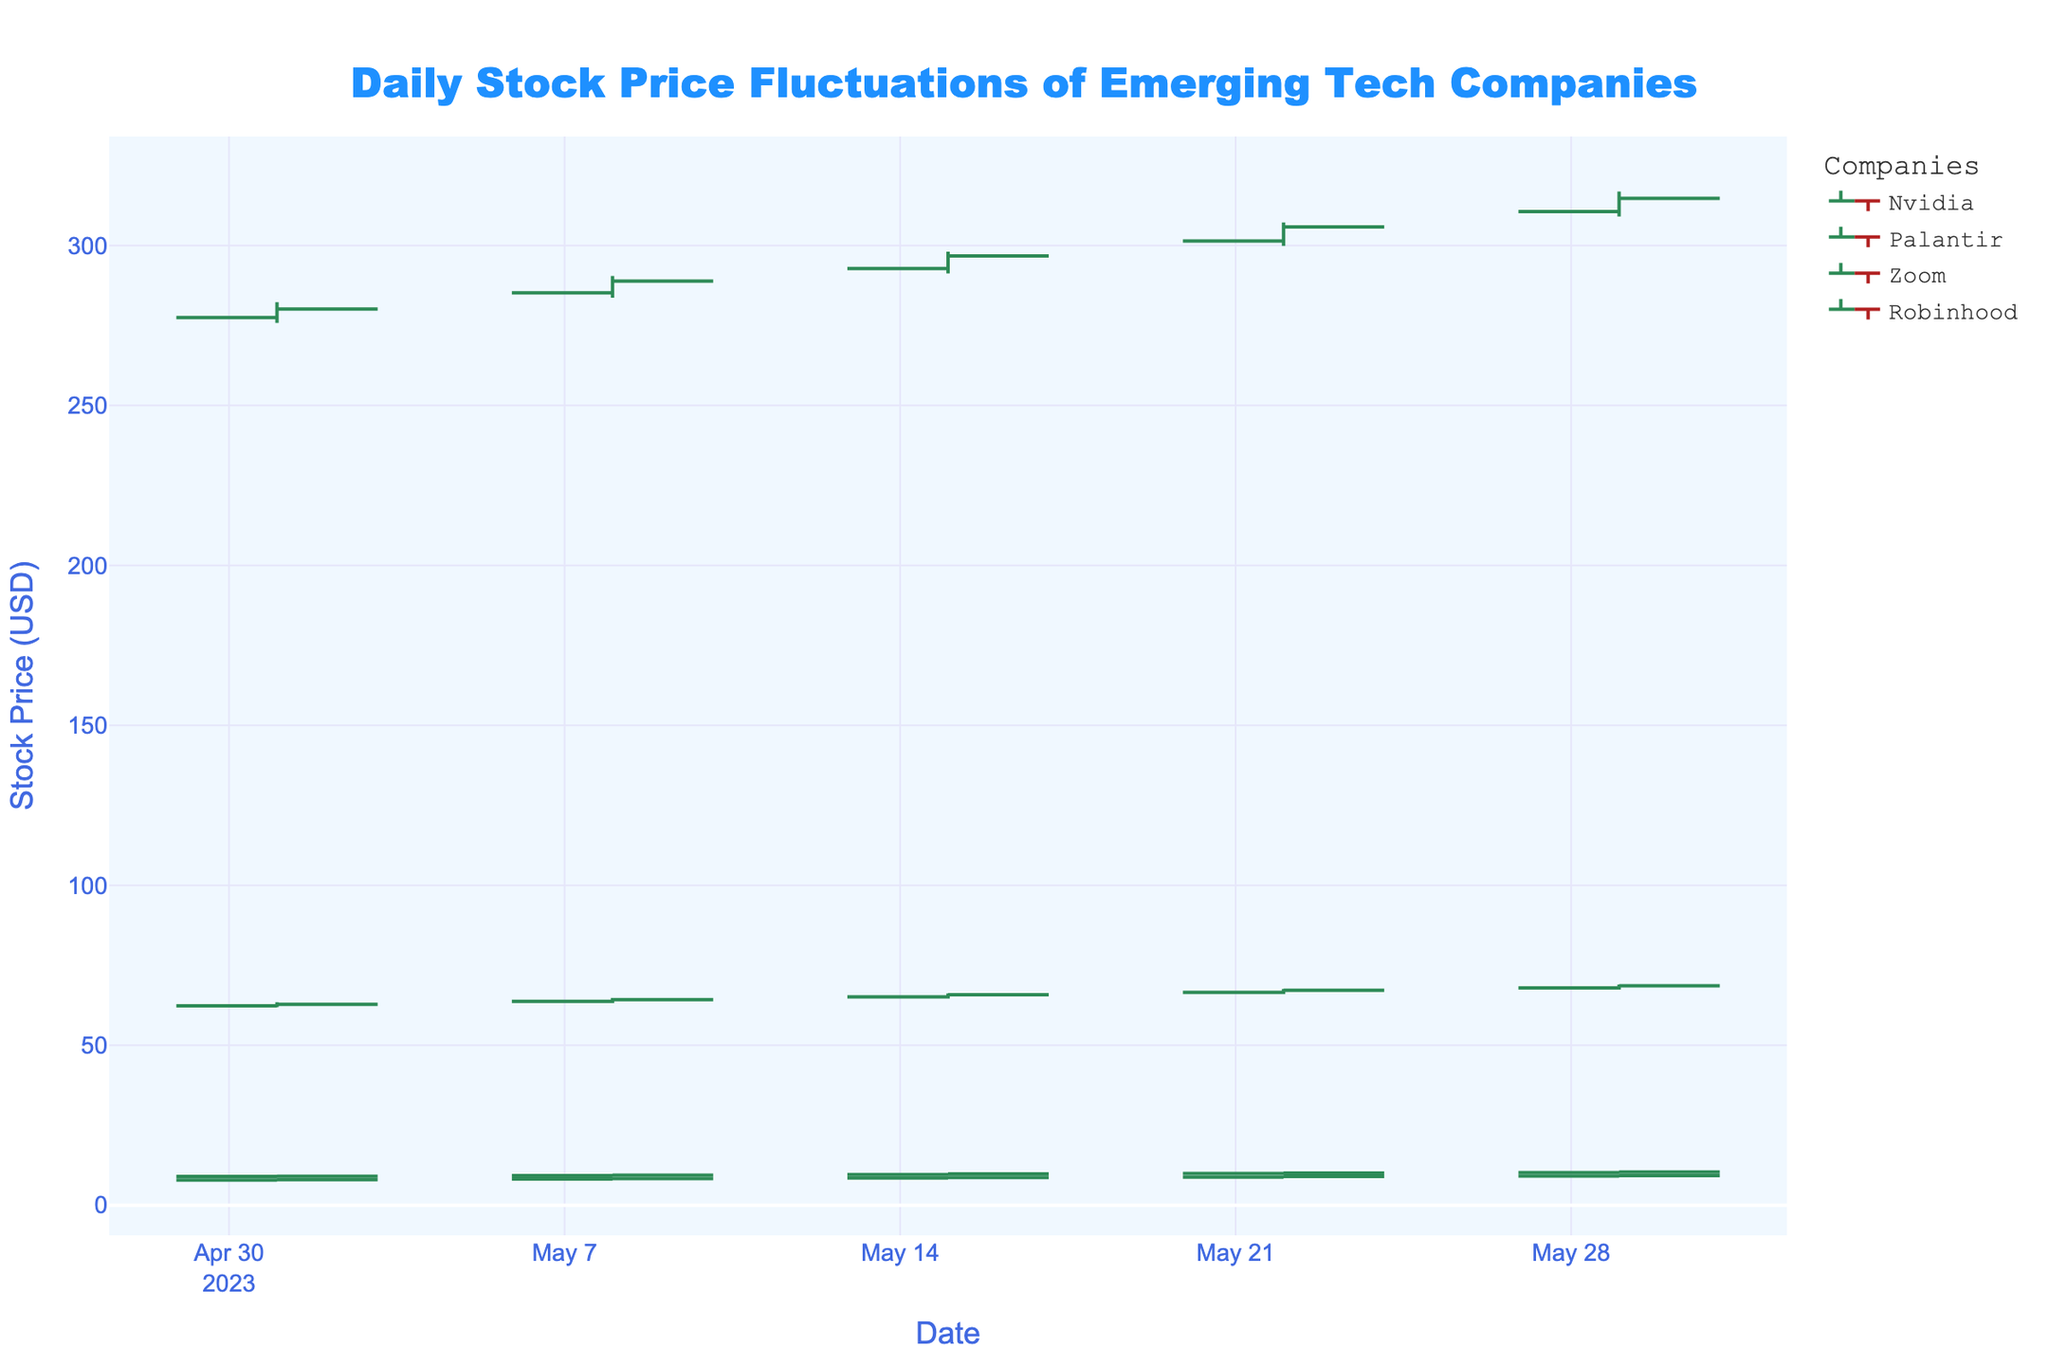what is the highest closing price of Nvidia in May? To find Nvidia's highest closing price in May, look at the 'Nvidia' series and identify the highest 'Close' value. The values are 280.15, 288.90, 296.75, 305.80, 314.75. The highest value is 314.75.
Answer: 314.75 Which company had the largest price increase within a day? To find which company had the largest price increase in a day, calculate the difference between 'High' and 'Low' for each company on all dates. The largest difference is for Nvidia on 2023-05-22: 307.20 - 299.90 = 7.30.
Answer: Nvidia On which date did Robinhood have its lowest closing price? To find out when Robinhood had its lowest closing price, check the 'Robinhood' series and find the date with the lowest 'Close' value. The values are 9.05, 9.40, 9.75, 10.05, 10.35, with the lowest being 9.05 on 2023-05-01.
Answer: 2023-05-01 Compare the average closing prices of Zoom and Palantir throughout May. Which one is higher? First, calculate the average closing price for each company. For Zoom: (62.80 + 64.25 + 65.80 + 67.20 + 68.60) / 5 = 65.33. For Palantir: (7.95 + 8.30 + 8.65 + 8.95 + 9.25) / 5 = 8.62. Zoom's average closing price is higher.
Answer: Zoom Did Palantir's closing price ever decrease compared to its opening price? For each day, check if 'Close' is lower than 'Open' for Palantir. On 2023-05-01: 7.95 (less than 7.85), 2023-05-08: 8.30 (greater than 8.15), 2023-05-15: 8.65 (greater than 8.50), 2023-05-22: 8.95 (greater than 8.80), and 2023-05-29: 9.25 (greater than 9.10).
Answer: No How much higher is Nvidia’s highest opening price than its lowest opening price in May? Nvidia's highest opening price in May is 310.60 (2023-05-29) and the lowest opening price is 277.50 (2023-05-01). The difference is 310.60 - 277.50 = 33.10.
Answer: 33.10 Which company shows the most consistent (least varied) daily range (High - Low) across the month? Calculate the daily range (High - Low) for each company for all dates. Find the one with the smallest variation (standard deviation). Robinhood: 9.20-8.85=0.35, 9.50-9.15=0.35, 9.85-9.50=0.35, 10.15-9.80=0.35, 10.45-10.10=0.35. All are the same.
Answer: Robinhood What is the general trend for Zoom's stock price over May? Observe the overall pattern of 'Close' values for Zoom throughout May: 62.80 (increasing), 64.25 (increasing), 65.80 (increasing), 67.20 (increasing), 68.60 (increasing). The trend is consistently upward.
Answer: Upward 